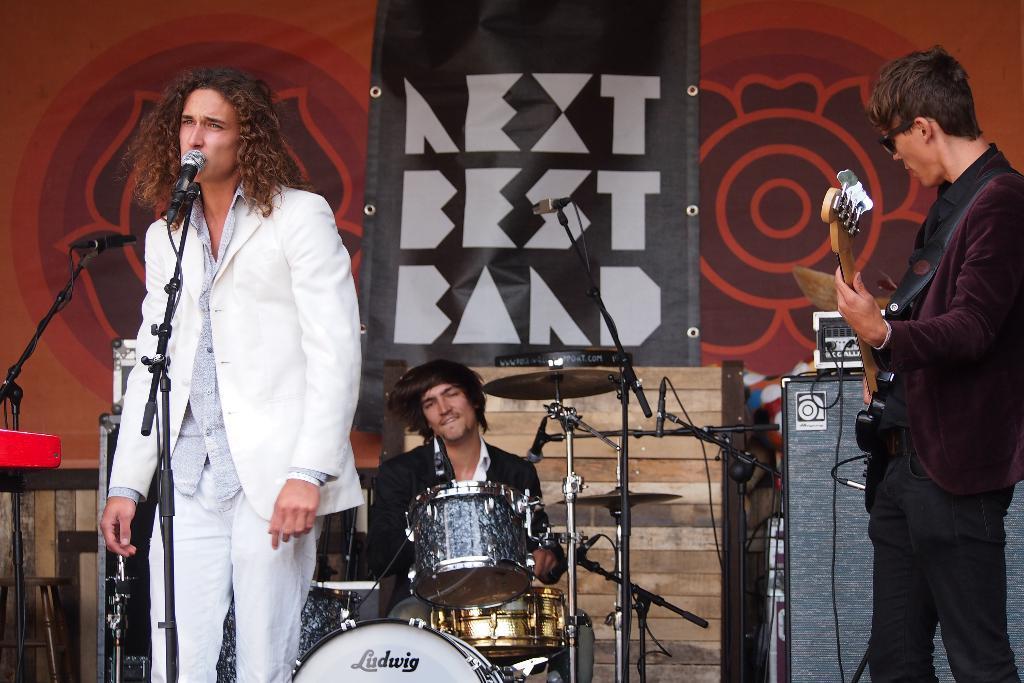Describe this image in one or two sentences. This picture is kept in a musical concert. There are three men in this picture. Man on the left corner of the picture wearing white blazer is singing song on microphone. Man on the right corner of the picture wearing brown blazer is holding guitar in his hands and playing it. The man in the middle of the picture wearing black blazer is playing drums. Behind them, we see a wall which is red in color. 